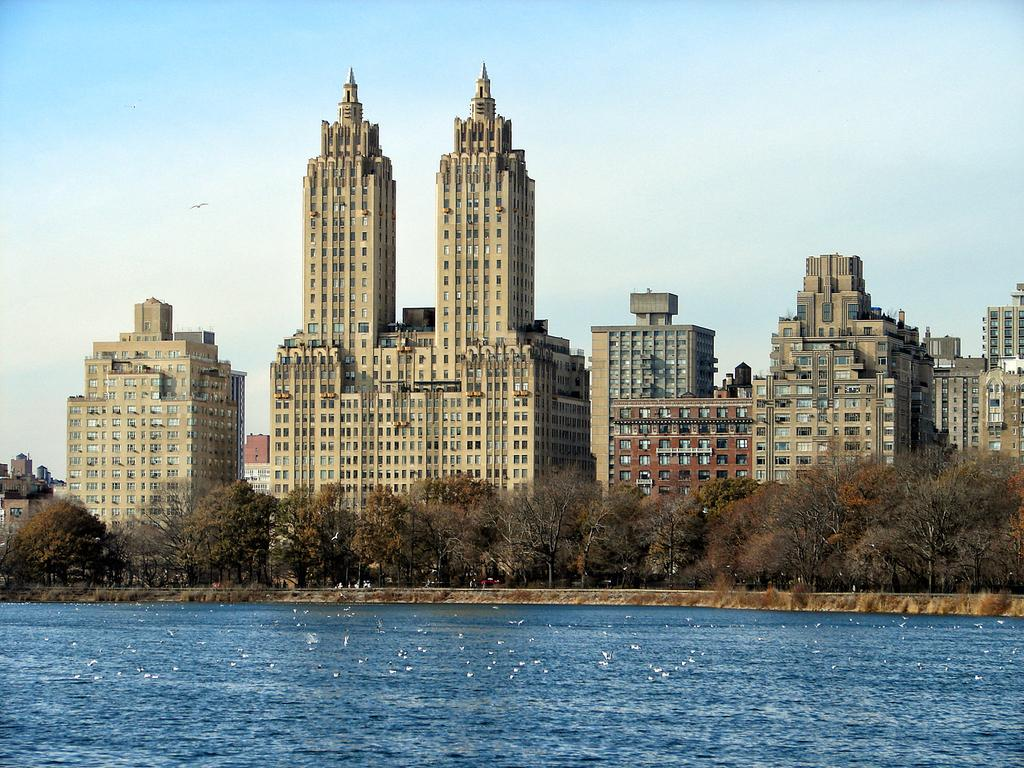What is visible in the image that is not a solid structure? Water is visible in the image. What type of vegetation can be seen in the image? There are trees in the image. What animals are present in the image? Birds are flying in the air in the image. What type of buildings can be seen in the image? Tower buildings are present in the image. What is visible in the background of the image? The sky is visible in the background of the image. How many beans are being divided among the birds in the image? There are no beans present in the image, and the birds are not engaged in any division activity. Can you tell me how many times the person in the image sneezes? There is no person present in the image, and therefore no sneezing can be observed. 